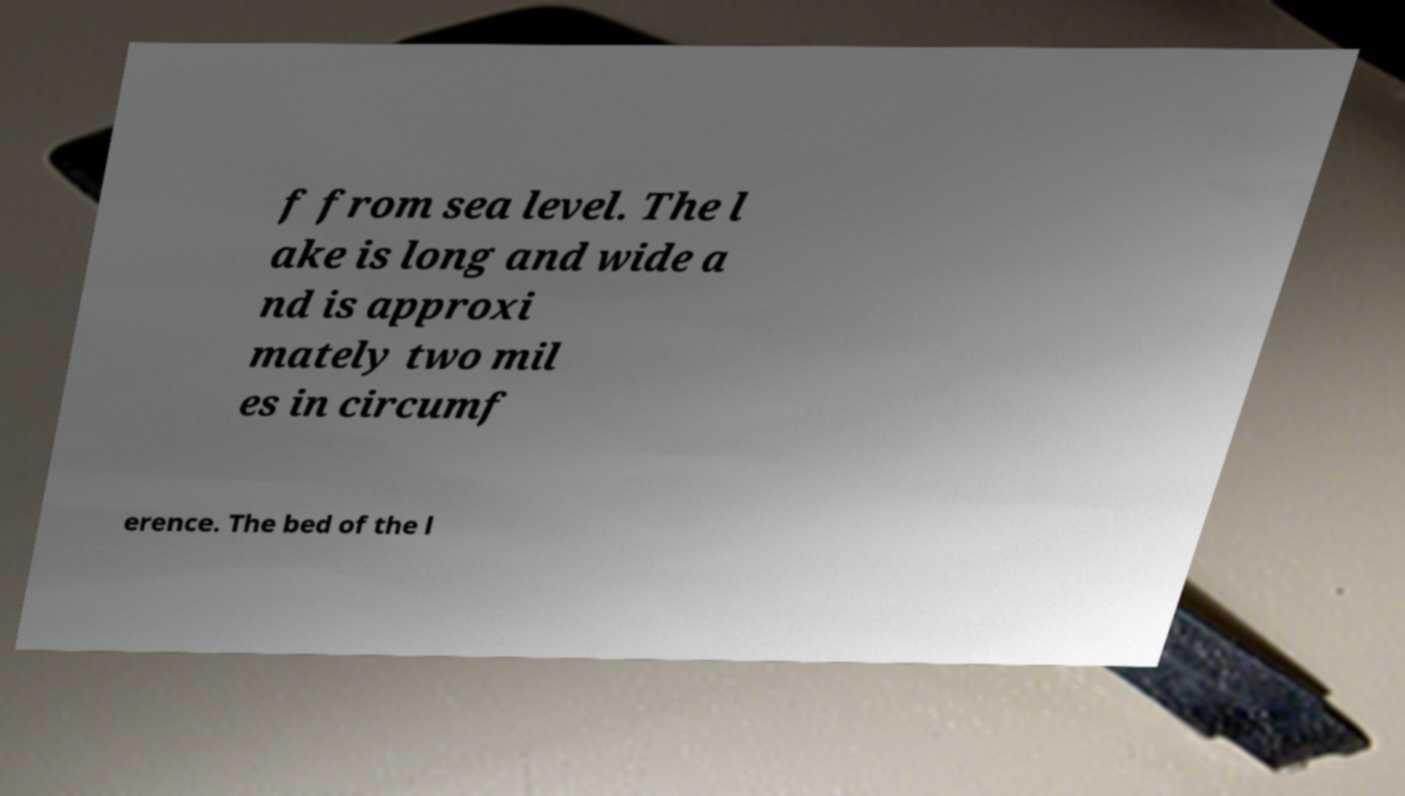Please identify and transcribe the text found in this image. f from sea level. The l ake is long and wide a nd is approxi mately two mil es in circumf erence. The bed of the l 